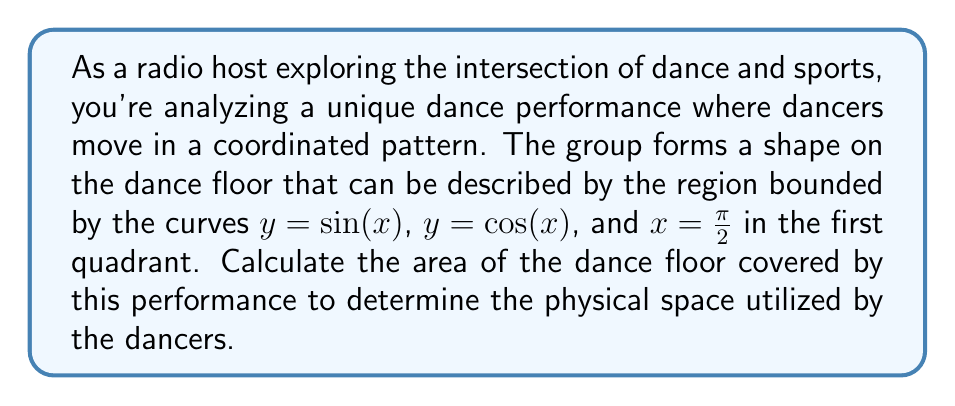Show me your answer to this math problem. To solve this problem, we need to use integration to find the area between the given curves. Let's approach this step-by-step:

1) First, we need to determine the intersection points of $y = \sin(x)$ and $y = \cos(x)$ in the first quadrant.
   These curves intersect when $\sin(x) = \cos(x)$, which occurs at $x = \frac{\pi}{4}$.

2) Now, we can set up our integral. We'll integrate the difference between the upper and lower curves from $x = 0$ to $x = \frac{\pi}{2}$:

   $$A = \int_{0}^{\frac{\pi}{2}} [\max(\sin(x), \cos(x)) - \min(\sin(x), \cos(x))] dx$$

3) We can split this integral at the intersection point:

   $$A = \int_{0}^{\frac{\pi}{4}} [\cos(x) - \sin(x)] dx + \int_{\frac{\pi}{4}}^{\frac{\pi}{2}} [\sin(x) - \cos(x)] dx$$

4) Let's solve each integral separately:

   For the first integral:
   $$\int_{0}^{\frac{\pi}{4}} [\cos(x) - \sin(x)] dx = [\sin(x) + \cos(x)]_{0}^{\frac{\pi}{4}}$$
   $$= (\frac{\sqrt{2}}{2} + \frac{\sqrt{2}}{2}) - (0 + 1) = \sqrt{2} - 1$$

   For the second integral:
   $$\int_{\frac{\pi}{4}}^{\frac{\pi}{2}} [\sin(x) - \cos(x)] dx = [-\cos(x) - \sin(x)]_{\frac{\pi}{4}}^{\frac{\pi}{2}}$$
   $$= (-0 - 1) - (-\frac{\sqrt{2}}{2} - \frac{\sqrt{2}}{2}) = -1 + \sqrt{2}$$

5) The total area is the sum of these two integrals:

   $$A = (\sqrt{2} - 1) + (-1 + \sqrt{2}) = 2\sqrt{2} - 2$$

Therefore, the area of the dance floor covered by the performance is $2\sqrt{2} - 2$ square units.
Answer: $2\sqrt{2} - 2$ square units 